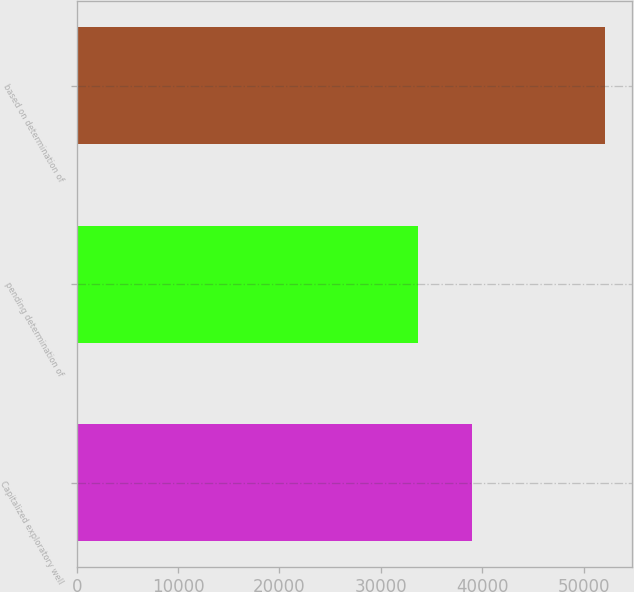Convert chart to OTSL. <chart><loc_0><loc_0><loc_500><loc_500><bar_chart><fcel>Capitalized exploratory well<fcel>pending determination of<fcel>based on determination of<nl><fcel>39040.5<fcel>33671<fcel>52138<nl></chart> 